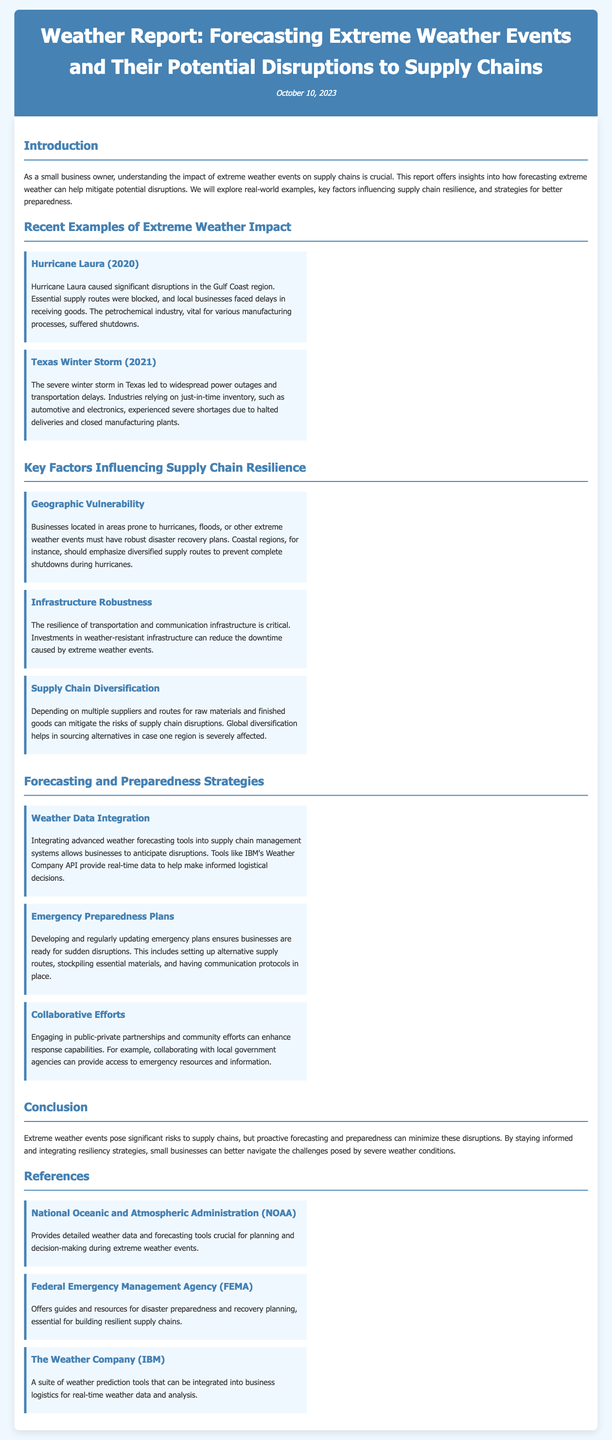What is the title of the report? The title is stated at the top of the document as "Weather Report: Forecasting Extreme Weather Events and Their Potential Disruptions to Supply Chains."
Answer: Weather Report: Forecasting Extreme Weather Events and Their Potential Disruptions to Supply Chains When was the report published? The publication date is mentioned directly under the title as "October 10, 2023."
Answer: October 10, 2023 Which hurricane caused significant disruptions in 2020? The report provides a specific example of Hurricane Laura occurring in 2020 that caused significant disruptions.
Answer: Hurricane Laura What factor is related to businesses located in vulnerable geographic areas? The document mentions that businesses in these areas "must have robust disaster recovery plans."
Answer: Robust disaster recovery plans What is one strategy for preparing for extreme weather disruptions? The report highlights "Weather Data Integration" as a strategy for anticipating disruptions in supply chains.
Answer: Weather Data Integration Which organization provides guides for disaster preparedness? The report lists FEMA as a source that offers guides and resources for disaster preparedness and recovery planning.
Answer: Federal Emergency Management Agency (FEMA) What event led to transportation delays in Texas in 2021? The document cites the "Texas Winter Storm" as a significant event that caused transportation delays in 2021.
Answer: Texas Winter Storm What is one impact of extreme weather on supply chains mentioned in the report? The document describes that extreme weather events can lead to "delays in receiving goods."
Answer: Delays in receiving goods Which company offers advanced weather prediction tools? The report mentions "The Weather Company (IBM)" as a provider of weather prediction tools integrated into business logistics.
Answer: The Weather Company (IBM) 